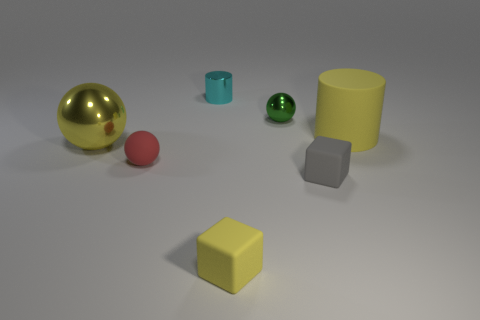The shiny thing that is the same color as the large cylinder is what shape?
Provide a succinct answer. Sphere. What material is the sphere behind the big metal thing?
Make the answer very short. Metal. Does the small red object have the same shape as the cyan thing?
Make the answer very short. No. What number of other objects are the same shape as the small red rubber object?
Give a very brief answer. 2. There is a small metal object to the right of the small yellow rubber cube; what color is it?
Offer a terse response. Green. Does the yellow cube have the same size as the gray matte block?
Offer a terse response. Yes. What material is the cylinder that is behind the yellow object to the right of the gray cube made of?
Make the answer very short. Metal. How many other metal cylinders are the same color as the small cylinder?
Provide a succinct answer. 0. Is the number of tiny rubber spheres in front of the gray block less than the number of large shiny things?
Your answer should be very brief. Yes. What color is the large thing to the left of the small object that is on the left side of the tiny cyan shiny cylinder?
Offer a terse response. Yellow. 